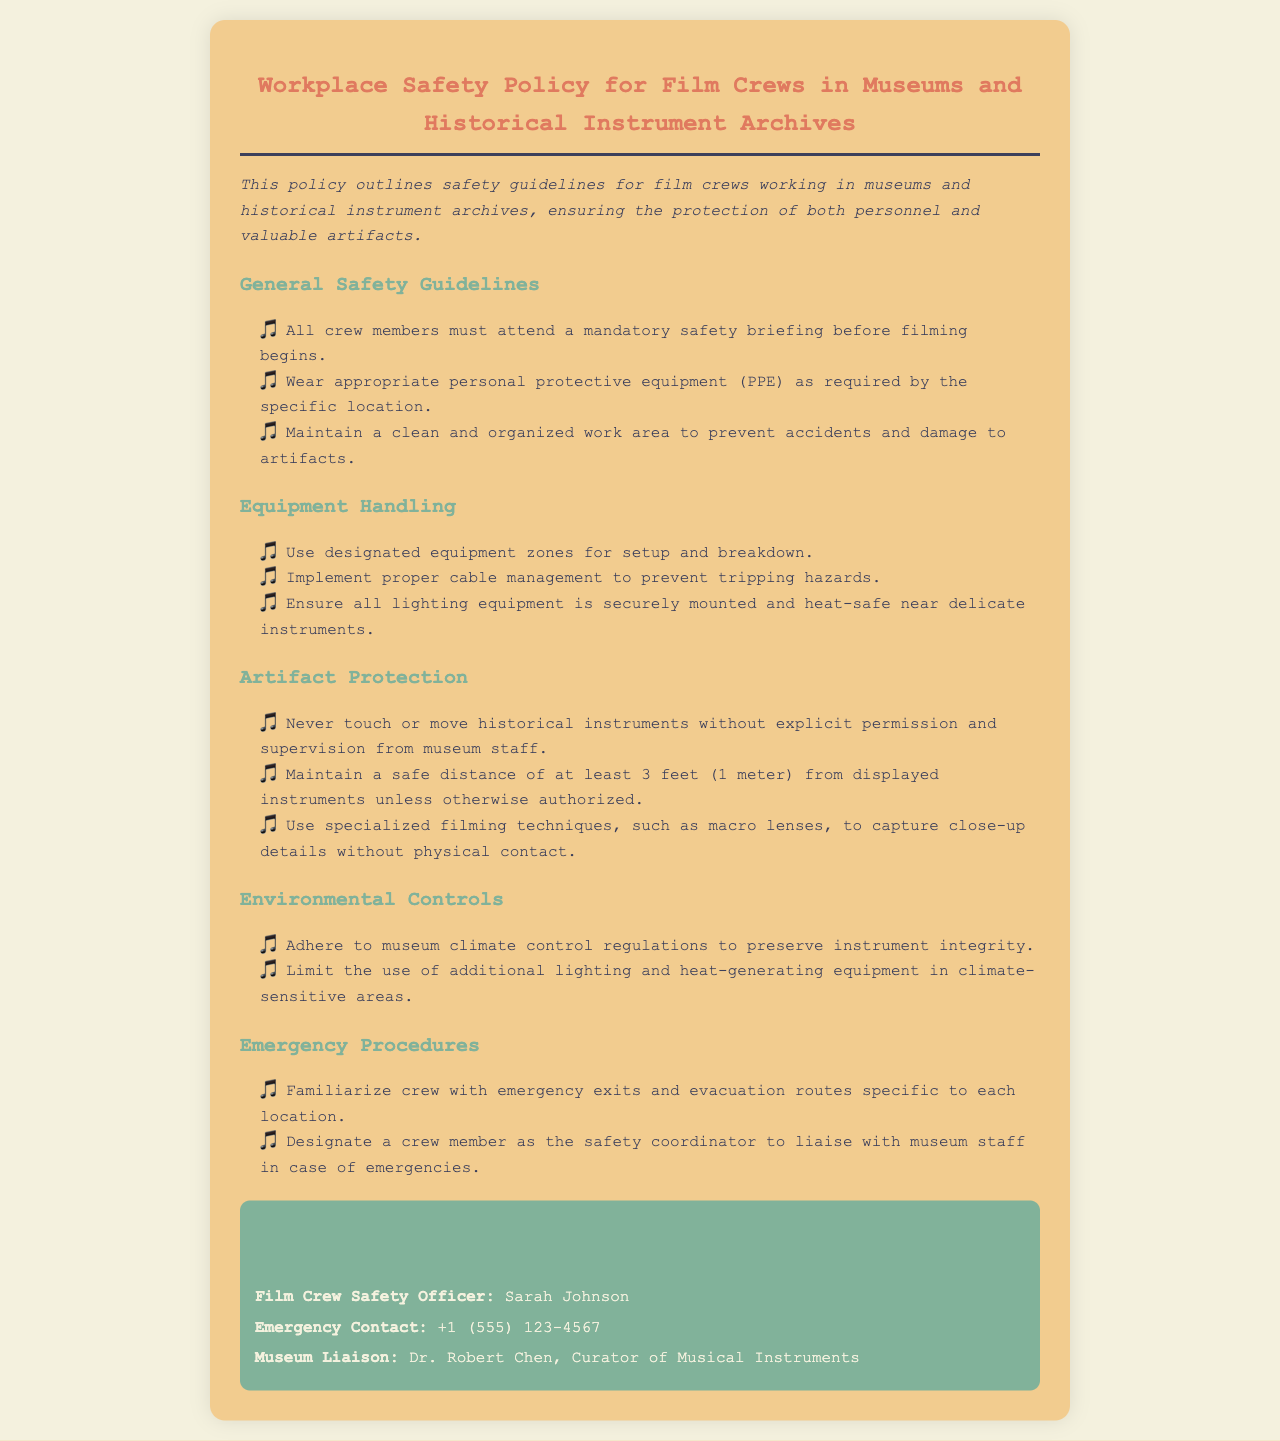What is the title of the policy document? The title is clearly stated at the top of the document as "Workplace Safety Policy for Film Crews in Museums and Historical Instrument Archives."
Answer: Workplace Safety Policy for Film Crews in Museums and Historical Instrument Archives Who is the Film Crew Safety Officer? The document specifies the name of the Film Crew Safety Officer mentioned in the contact information section.
Answer: Sarah Johnson What is the minimum safe distance from displayed instruments? The document explicitly states the required safe distance to maintain from displayed instruments.
Answer: 3 feet What specific equipment management practice is mentioned? The policy highlights proper cable management to prevent certain hazards, which is detailed under the Equipment Handling section.
Answer: Cable management What is the primary goal of the policy? The policy outlines its main purpose in the introductory sentence, highlighting who or what it is meant to protect.
Answer: Protection of personnel and valuable artifacts Who is the Museum Liaison listed in the document? The contact information section provides the name of the designated liaison for museum affairs.
Answer: Dr. Robert Chen What should crew members do before filming begins? The initial guidelines in the document specify a requirement before the crew starts any filming activities.
Answer: Attend a mandatory safety briefing What should be limited in climate-sensitive areas? The Environmental Controls section emphasizes a specific limitation regarding equipment in sensitive areas.
Answer: Use of additional lighting and heat-generating equipment What does the policy emphasize about historical instruments? The Artifact Protection section underscores a particular action regarding historical instruments that must be followed.
Answer: Never touch or move without permission 